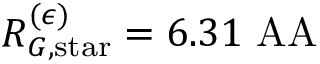Convert formula to latex. <formula><loc_0><loc_0><loc_500><loc_500>R _ { G , s t a r } ^ { ( \epsilon ) } = 6 . 3 1 \ A A</formula> 